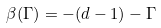<formula> <loc_0><loc_0><loc_500><loc_500>\beta ( \Gamma ) = - ( d - 1 ) - \Gamma</formula> 